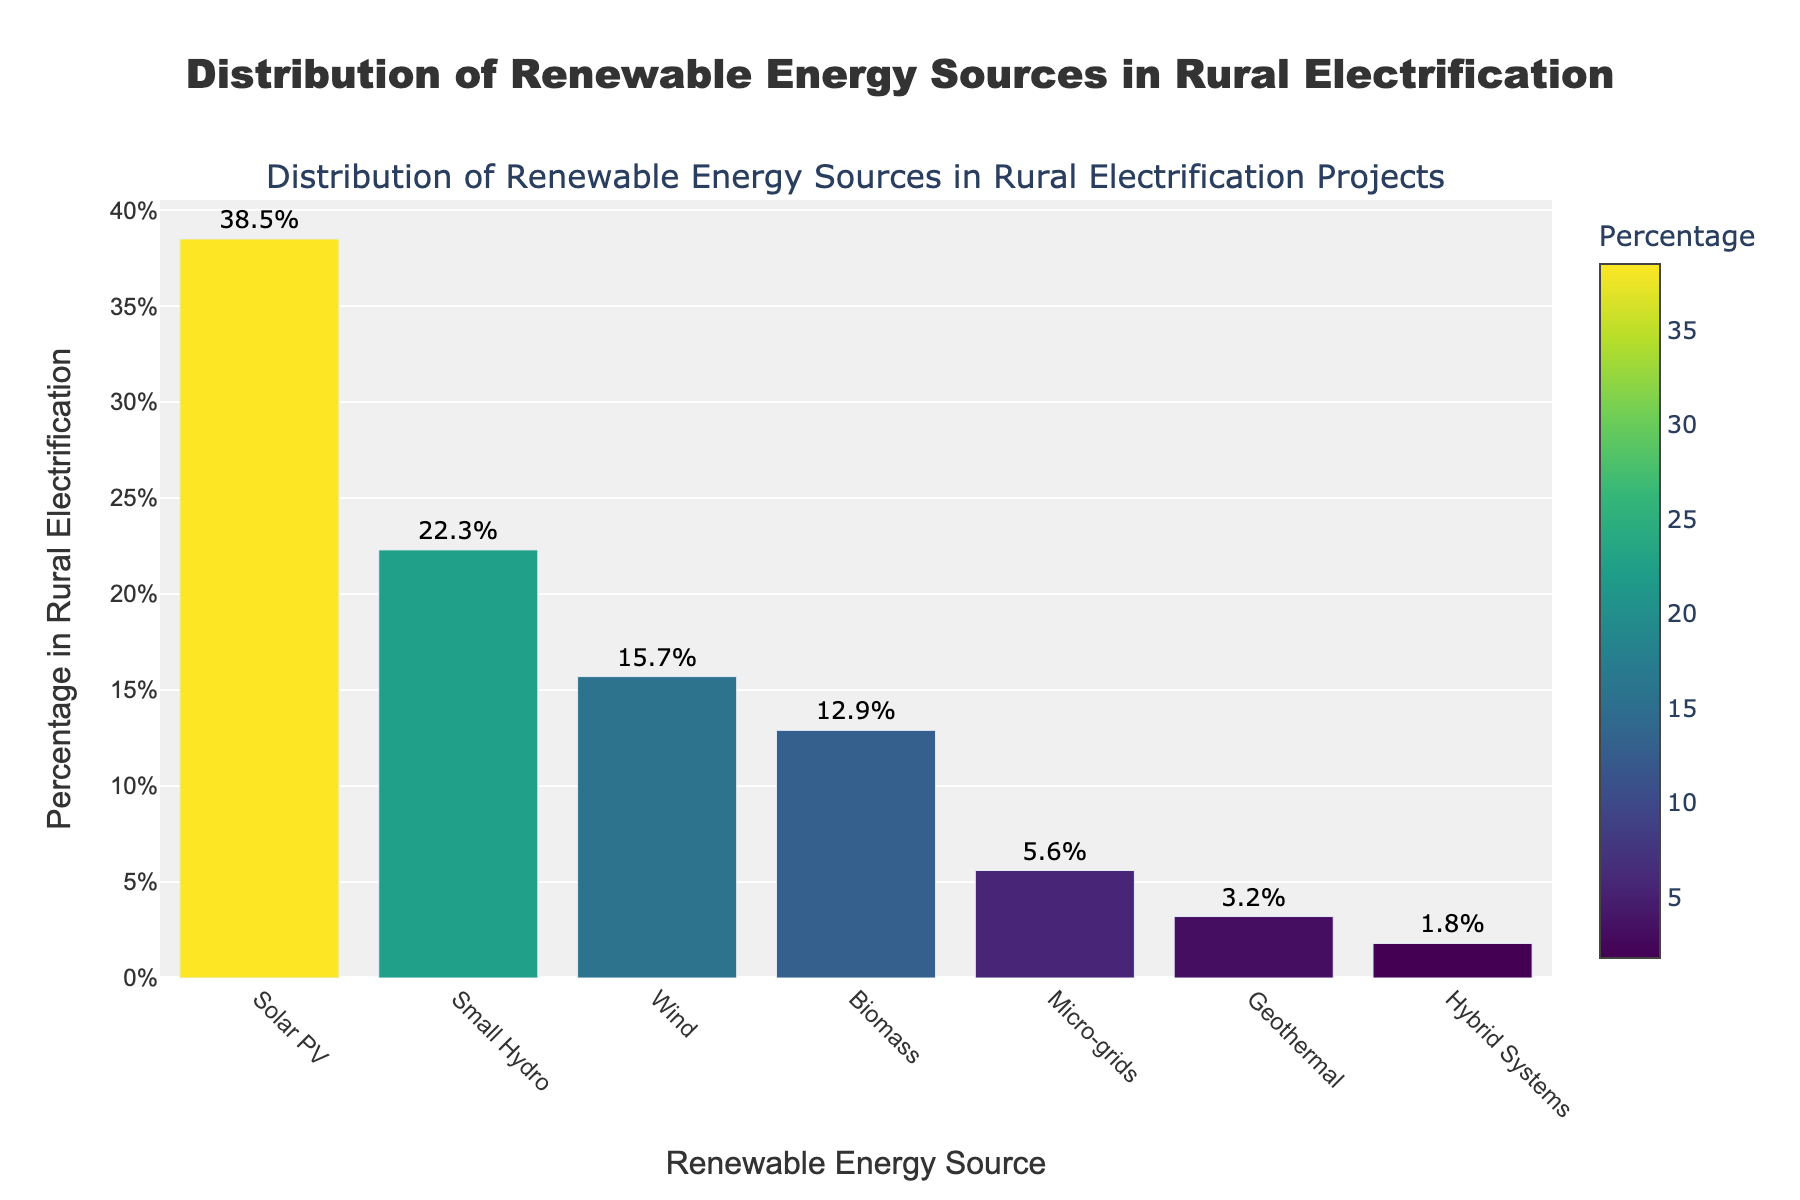Which renewable energy source has the highest percentage in rural electrification projects? The bar labeled "Solar PV" is the tallest, indicating it has the highest percentage.
Answer: Solar PV Which renewable energy source has the lowest percentage share in rural electrification projects? The bar labeled "Hybrid Systems" is the shortest, representing the smallest percentage in the chart.
Answer: Hybrid Systems How much more percentage does Solar PV have compared to Wind? Subtract the percentage of Wind (15.7%) from that of Solar PV (38.5%). 38.5% - 15.7% = 22.8%
Answer: 22.8% What is the total percentage share of Small Hydro and Geothermal combined? Add the percentages of Small Hydro (22.3%) and Geothermal (3.2%). 22.3% + 3.2% = 25.5%
Answer: 25.5% Is the percentage of Micro-grids higher or lower than Biomass? The height of the bar for Biomass (12.9%) is greater than the height of the bar for Micro-grids (5.6%), indicating Biomass has a higher percentage.
Answer: Lower How many sources have a percentage share above 20%? Count the bars with more than 20%: Solar PV (38.5%) and Small Hydro (22.3%) are the only ones.
Answer: 2 Which energy sources have a percentage share between 10% and 20%? Identify the bars falling within this range: Wind (15.7%) and Biomass (12.9%).
Answer: Wind and Biomass What is the approximate percentage difference between Biomass and Hybrid Systems? Subtract the percentage of Hybrid Systems (1.8%) from that of Biomass (12.9%). 12.9% - 1.8% = 11.1%
Answer: 11.1% Which color represents the energy source with the third highest percentage? The third highest percentage is Wind (15.7%), look for the third tallest bar and its associated color, which is a shade of green.
Answer: Green What is the average percentage for all renewable energy sources listed? Sum all the percentages and divide by the number of sources: (38.5 + 22.3 + 15.7 + 12.9 + 5.6 + 3.2 + 1.8) / 7 = 100 / 7 ≈ 14.3%
Answer: 14.3% 